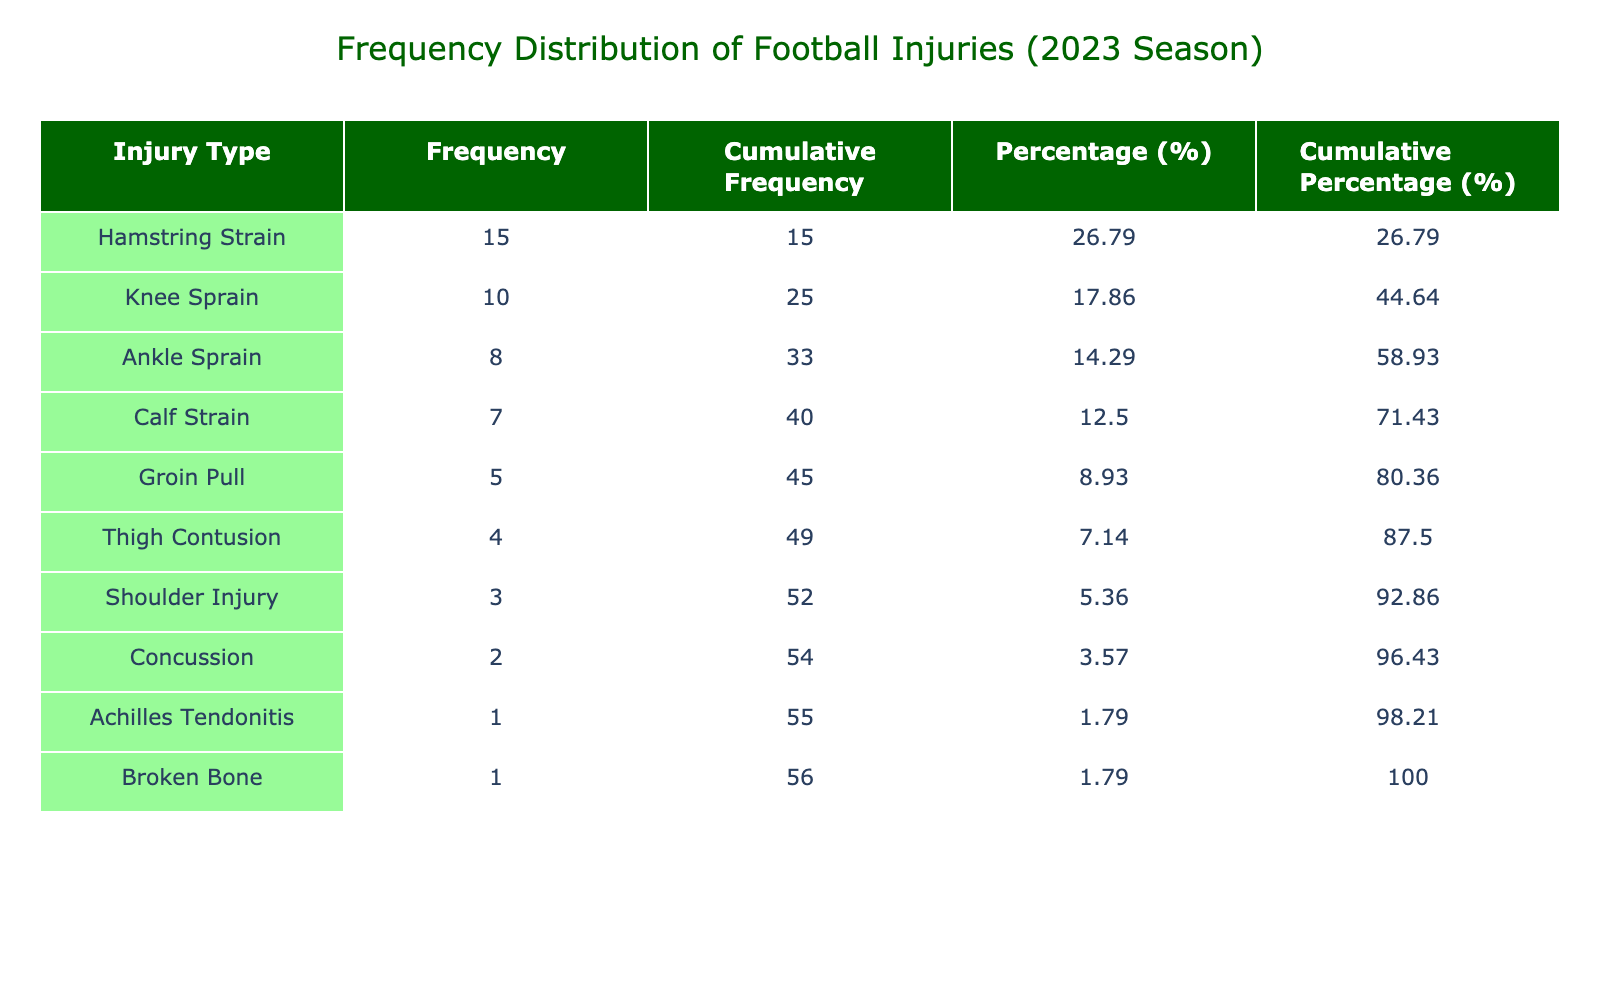What is the most common type of injury reported in the table? The table shows that the injury type with the highest frequency is Hamstring Strain, which has a frequency of 15.
Answer: Hamstring Strain How many players suffered from Knee Sprains? According to the table, the frequency column indicates that there were 10 players with Knee Sprains.
Answer: 10 What is the cumulative frequency of injuries after the Calf Strain? To find the cumulative frequency after Calf Strain, we add the frequencies of Hamstring Strain (15), Knee Sprain (10), Ankle Sprain (8), Groin Pull (5), and Calf Strain (7): 15 + 10 + 8 + 5 + 7 = 45.
Answer: 45 Is the frequency of Concussions greater than the frequency of Shoulder Injuries? From the table, we see that the frequency of Concussions is 2 and the frequency of Shoulder Injuries is 3. Since 2 is not greater than 3, the answer is false.
Answer: No What percentage of injuries are due to Groin Pulls? The frequency of Groin Pulls is 5, and the total frequency of all injuries is 61. The percentage is calculated as (5/61) * 100 = 8.2, rounded to two decimal places gives 8.20%.
Answer: 8.20 What is the difference in frequency between the most common injury and the least common injury? The most common injury is Hamstring Strain with a frequency of 15, and the least common injury is both Achilles Tendonitis and Broken Bone, each with a frequency of 1. Therefore, the difference is 15 - 1 = 14.
Answer: 14 How many types of injuries have a frequency of 5 or less? By examining the table, we can see that the injuries with a frequency of 5 or less are Thigh Contusion (4), Shoulder Injury (3), Concussion (2), Achilles Tendonitis (1), and Broken Bone (1). Counting these, we find there are 5 such injuries.
Answer: 5 What is the cumulative percentage of injuries from Hamstring Strain and Knee Sprain? The cumulative percentage for Hamstring Strain is 24.39%, and for Knee Sprain, it adds another 16.39% (cumulative percentage for Knee Sprain). So, the cumulative percentage is 24.39 + 16.39 = 40.78%.
Answer: 40.78 Can you name an injury type that has a lower frequency than 5? Yes, several injury types have a frequency lower than 5 which include Thigh Contusion (4), Shoulder Injury (3), Concussion (2), Achilles Tendonitis (1), and Broken Bone (1).
Answer: Yes 